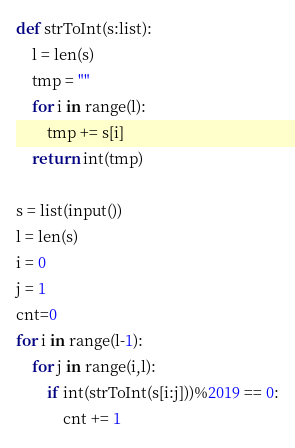Convert code to text. <code><loc_0><loc_0><loc_500><loc_500><_Python_>def strToInt(s:list):
    l = len(s)
    tmp = ""
    for i in range(l):
        tmp += s[i]
    return int(tmp)

s = list(input())
l = len(s)
i = 0
j = 1
cnt=0
for i in range(l-1):
    for j in range(i,l):
        if int(strToInt(s[i:j]))%2019 == 0:
            cnt += 1
</code> 